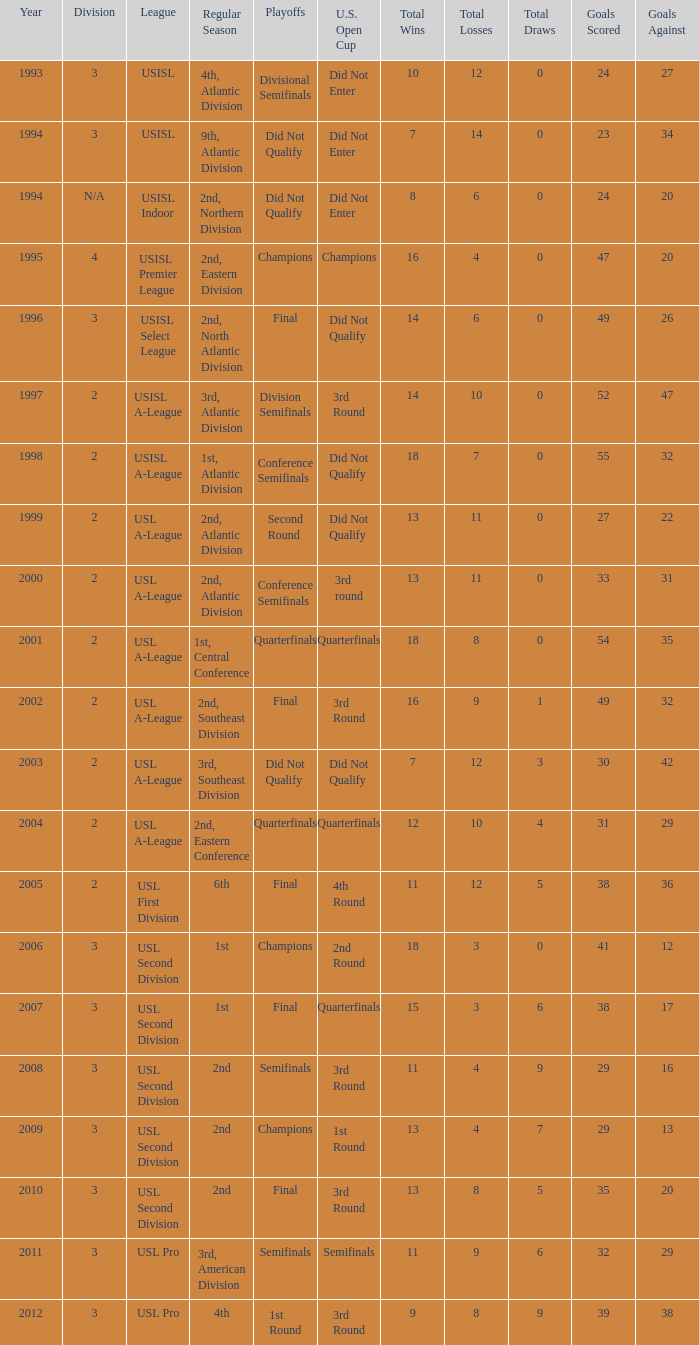What's the u.s. open cup status for regular season of 4th, atlantic division  Did Not Enter. 